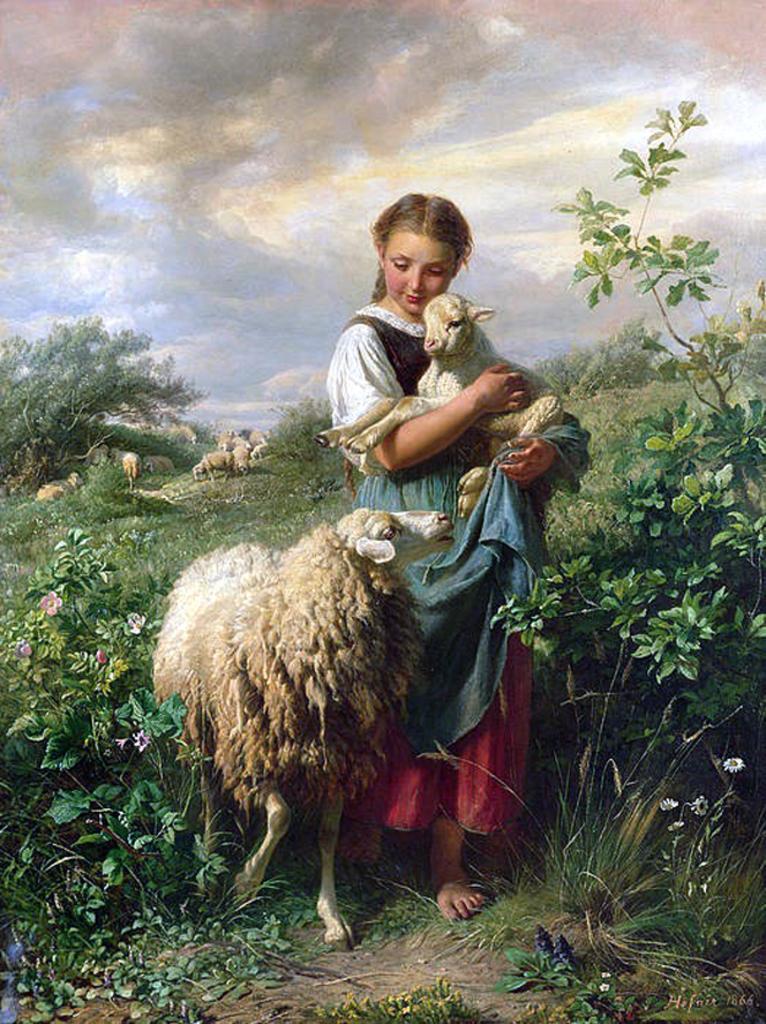Could you give a brief overview of what you see in this image? This is a panting. In this painting there is a sheep. Near to that a girl is holding a lamb. Also there are plants and sky with clouds. 